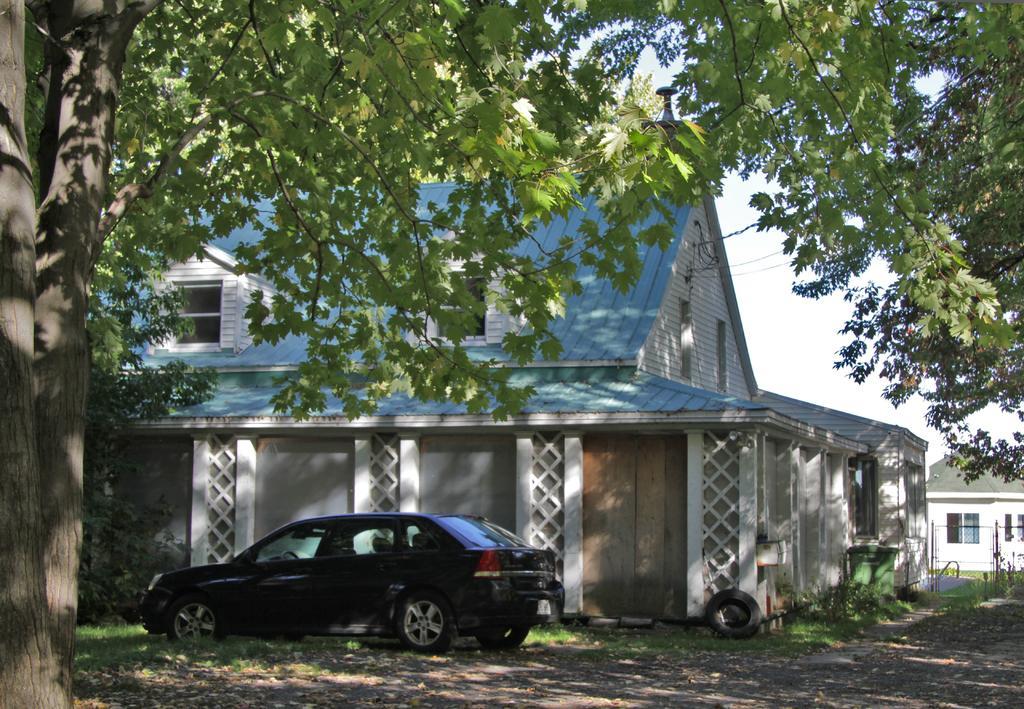Could you give a brief overview of what you see in this image? In this image I can see on the left side there is a car, in the middle there are houses. There are trees on either side of this image, at the top it is the sky. 